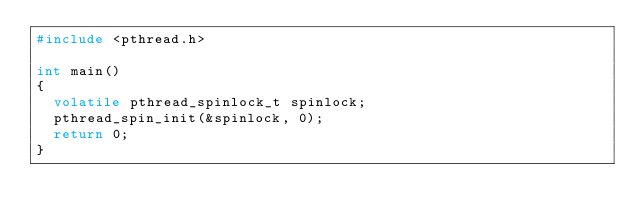<code> <loc_0><loc_0><loc_500><loc_500><_C++_>#include <pthread.h>

int main()
{
	volatile pthread_spinlock_t spinlock;
	pthread_spin_init(&spinlock, 0);
	return 0;
}
</code> 